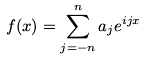<formula> <loc_0><loc_0><loc_500><loc_500>f ( x ) = \sum _ { j = - n } ^ { n } a _ { j } e ^ { i j x }</formula> 